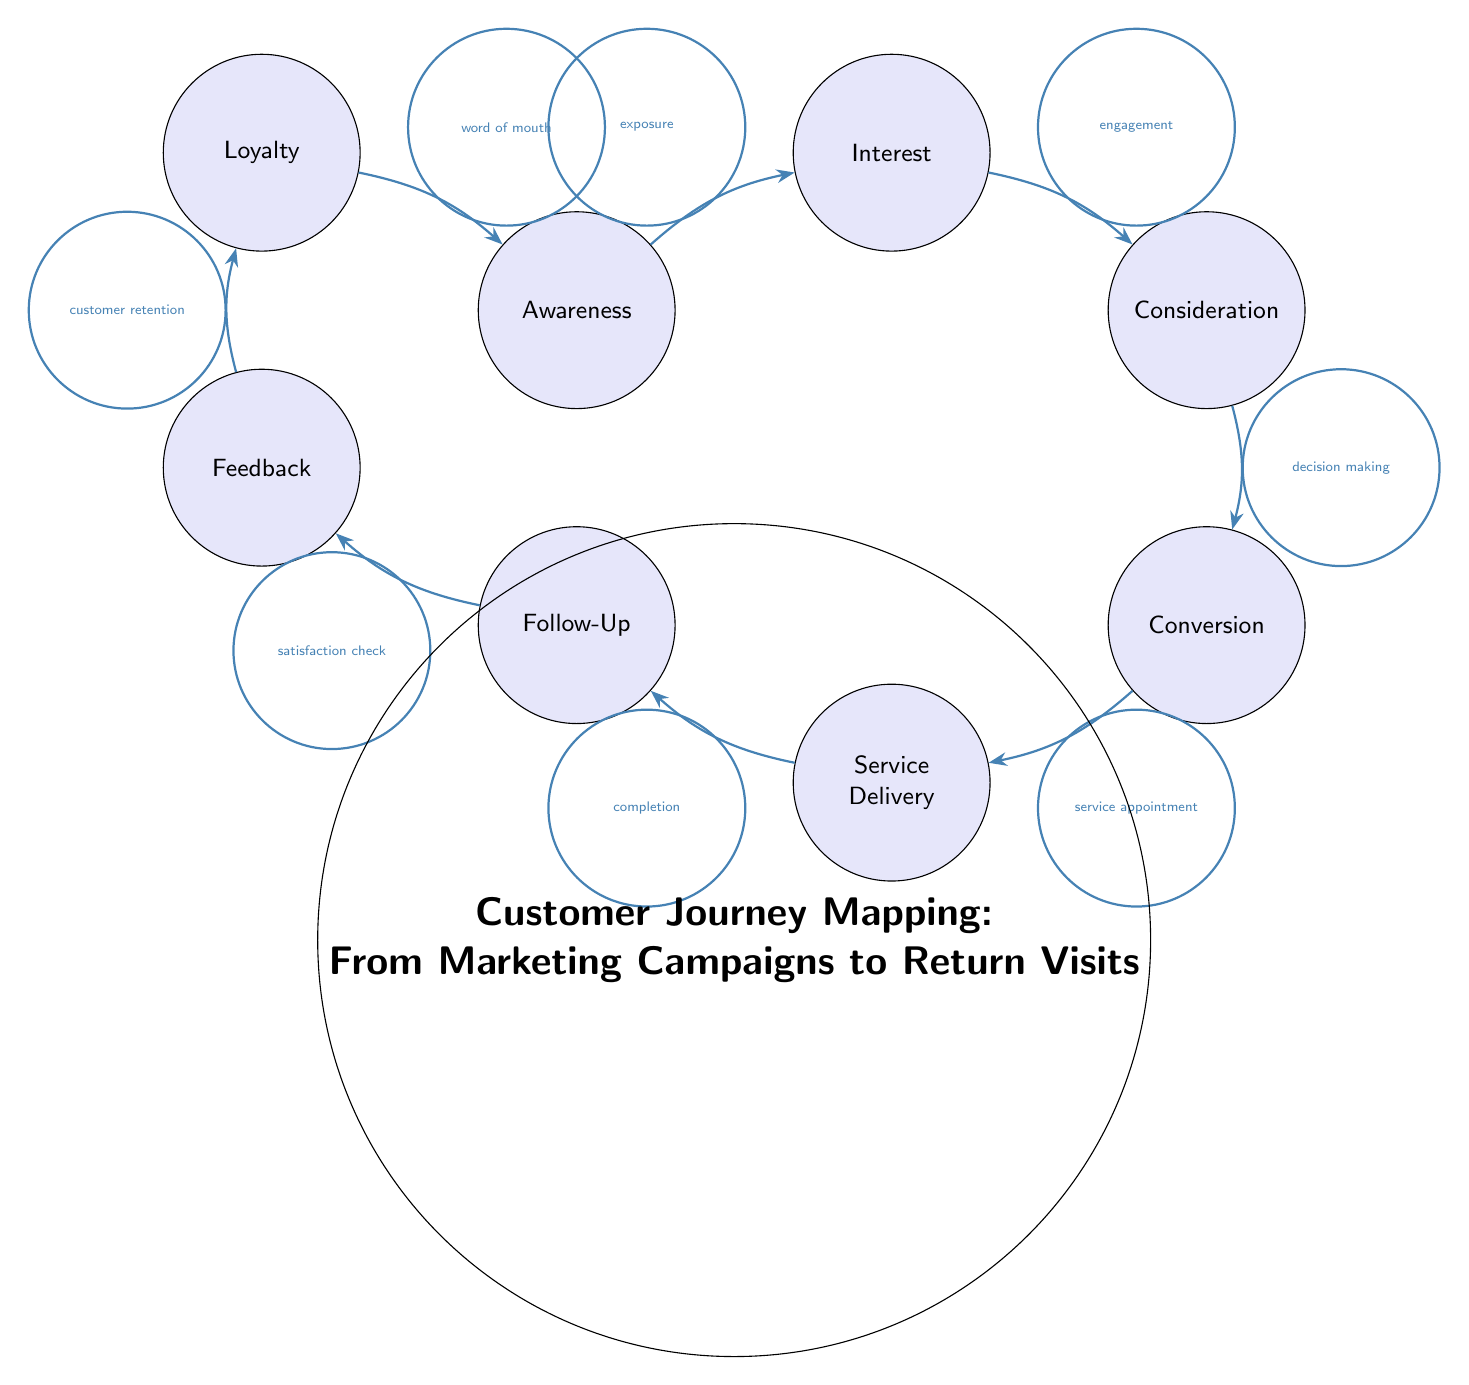What is the starting point of the customer journey? The starting point of the customer journey is labeled as "Awareness" in the diagram, indicating that this is where potential customers first become aware of the business.
Answer: Awareness How many nodes are present in the diagram? By counting each labeled circle in the diagram, we notice there are a total of eight individual nodes representing different stages of the customer journey.
Answer: 8 What action connects "Follow-Up" to "Feedback"? The action connecting "Follow-Up" to "Feedback" is labeled as "satisfaction check," indicating that after service delivery, a follow-up is conducted to check customer satisfaction.
Answer: satisfaction check Which node directly follows "Conversion"? Moving through the diagram from "Conversion," the next node that follows is "Service Delivery," marking the transition from a purchasing decision to receiving the actual service.
Answer: Service Delivery What is the relationship or action from "Loyalty" back to "Awareness"? The relationship from "Loyalty" back to "Awareness" is labeled as "word of mouth," suggesting that satisfied customers share their experiences, potentially generating new awareness for the business.
Answer: word of mouth What comes after "Interest" in the customer journey? Following the "Interest" stage, the next stage in the journey is "Consideration," which implies that interested customers begin evaluating options before making a decision.
Answer: Consideration What is the primary role of "Feedback" in the diagram? The primary role of "Feedback" is customer retention, as it emphasizes the importance of gathering input from customers to enhance their experience and ensure they return.
Answer: customer retention What action occurs between "Service Delivery" and "Follow-Up"? The action occurring between "Service Delivery" and "Follow-Up" is "completion," indicating that the completion of the service is necessary before a follow-up is made with the customer.
Answer: completion How does "Consideration" transition into "Conversion"? The transition from "Consideration" to "Conversion" happens through the action labeled "decision making," meaning that after considering their options, customers will decide to make a purchase.
Answer: decision making 